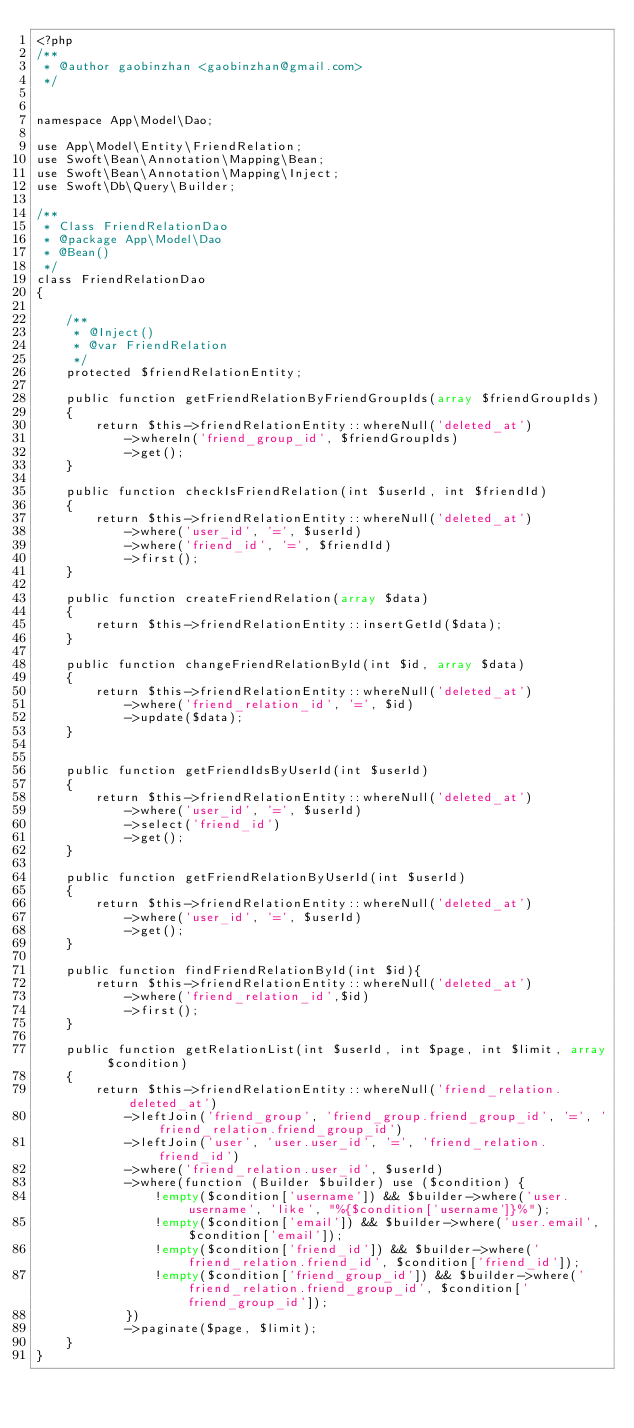Convert code to text. <code><loc_0><loc_0><loc_500><loc_500><_PHP_><?php
/**
 * @author gaobinzhan <gaobinzhan@gmail.com>
 */


namespace App\Model\Dao;

use App\Model\Entity\FriendRelation;
use Swoft\Bean\Annotation\Mapping\Bean;
use Swoft\Bean\Annotation\Mapping\Inject;
use Swoft\Db\Query\Builder;

/**
 * Class FriendRelationDao
 * @package App\Model\Dao
 * @Bean()
 */
class FriendRelationDao
{

    /**
     * @Inject()
     * @var FriendRelation
     */
    protected $friendRelationEntity;

    public function getFriendRelationByFriendGroupIds(array $friendGroupIds)
    {
        return $this->friendRelationEntity::whereNull('deleted_at')
            ->whereIn('friend_group_id', $friendGroupIds)
            ->get();
    }

    public function checkIsFriendRelation(int $userId, int $friendId)
    {
        return $this->friendRelationEntity::whereNull('deleted_at')
            ->where('user_id', '=', $userId)
            ->where('friend_id', '=', $friendId)
            ->first();
    }

    public function createFriendRelation(array $data)
    {
        return $this->friendRelationEntity::insertGetId($data);
    }

    public function changeFriendRelationById(int $id, array $data)
    {
        return $this->friendRelationEntity::whereNull('deleted_at')
            ->where('friend_relation_id', '=', $id)
            ->update($data);
    }


    public function getFriendIdsByUserId(int $userId)
    {
        return $this->friendRelationEntity::whereNull('deleted_at')
            ->where('user_id', '=', $userId)
            ->select('friend_id')
            ->get();
    }

    public function getFriendRelationByUserId(int $userId)
    {
        return $this->friendRelationEntity::whereNull('deleted_at')
            ->where('user_id', '=', $userId)
            ->get();
    }

    public function findFriendRelationById(int $id){
        return $this->friendRelationEntity::whereNull('deleted_at')
            ->where('friend_relation_id',$id)
            ->first();
    }

    public function getRelationList(int $userId, int $page, int $limit, array $condition)
    {
        return $this->friendRelationEntity::whereNull('friend_relation.deleted_at')
            ->leftJoin('friend_group', 'friend_group.friend_group_id', '=', 'friend_relation.friend_group_id')
            ->leftJoin('user', 'user.user_id', '=', 'friend_relation.friend_id')
            ->where('friend_relation.user_id', $userId)
            ->where(function (Builder $builder) use ($condition) {
                !empty($condition['username']) && $builder->where('user.username', 'like', "%{$condition['username']}%");
                !empty($condition['email']) && $builder->where('user.email', $condition['email']);
                !empty($condition['friend_id']) && $builder->where('friend_relation.friend_id', $condition['friend_id']);
                !empty($condition['friend_group_id']) && $builder->where('friend_relation.friend_group_id', $condition['friend_group_id']);
            })
            ->paginate($page, $limit);
    }
}
</code> 